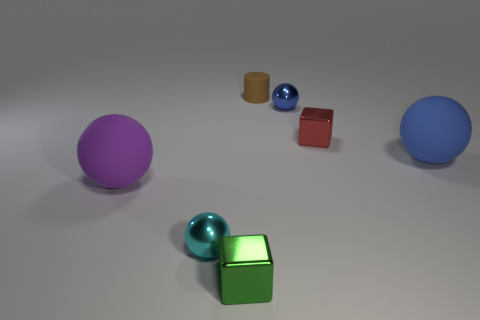What material is the purple thing that is the same shape as the cyan thing?
Give a very brief answer. Rubber. Do the tiny metal sphere that is behind the large purple rubber thing and the big rubber ball behind the purple thing have the same color?
Your response must be concise. Yes. What material is the large purple thing?
Your response must be concise. Rubber. Is the material of the small ball that is to the left of the brown object the same as the large purple ball that is left of the small rubber object?
Keep it short and to the point. No. How many blue shiny balls are the same size as the green metallic thing?
Give a very brief answer. 1. Is the size of the shiny sphere on the right side of the tiny cyan ball the same as the ball to the left of the tiny cyan metallic ball?
Offer a very short reply. No. What is the shape of the large matte thing right of the large purple rubber ball?
Ensure brevity in your answer.  Sphere. What material is the ball to the left of the tiny shiny sphere that is left of the tiny green metal block made of?
Provide a succinct answer. Rubber. Does the brown rubber object have the same size as the green object in front of the large purple matte sphere?
Make the answer very short. Yes. What number of red metal things are behind the shiny cube behind the tiny shiny ball that is to the left of the tiny green cube?
Offer a very short reply. 0. 